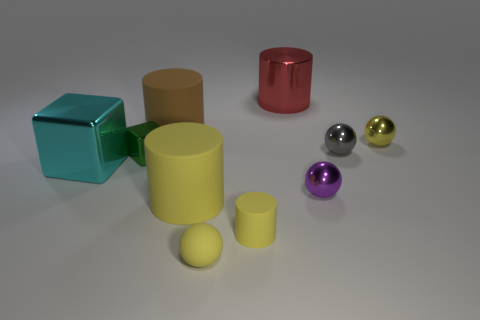Subtract 1 cylinders. How many cylinders are left? 3 Subtract all yellow balls. Subtract all brown cylinders. How many balls are left? 2 Subtract all balls. How many objects are left? 6 Add 1 yellow rubber objects. How many yellow rubber objects exist? 4 Subtract 0 gray cubes. How many objects are left? 10 Subtract all tiny green cylinders. Subtract all large metal things. How many objects are left? 8 Add 4 metal things. How many metal things are left? 10 